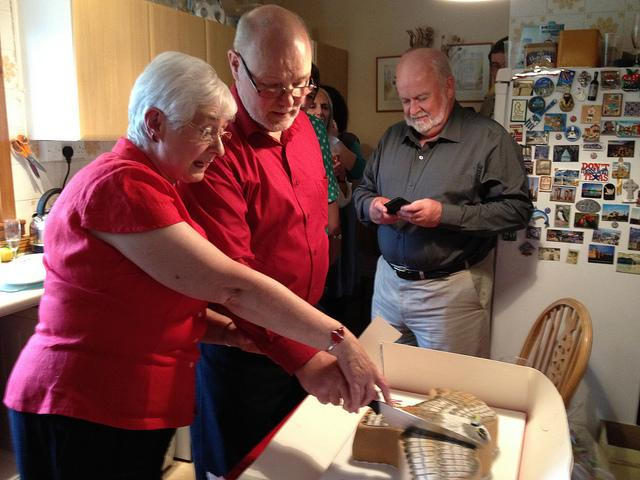What type of building are they in? Please explain your reasoning. residential. The house looks cozy. 